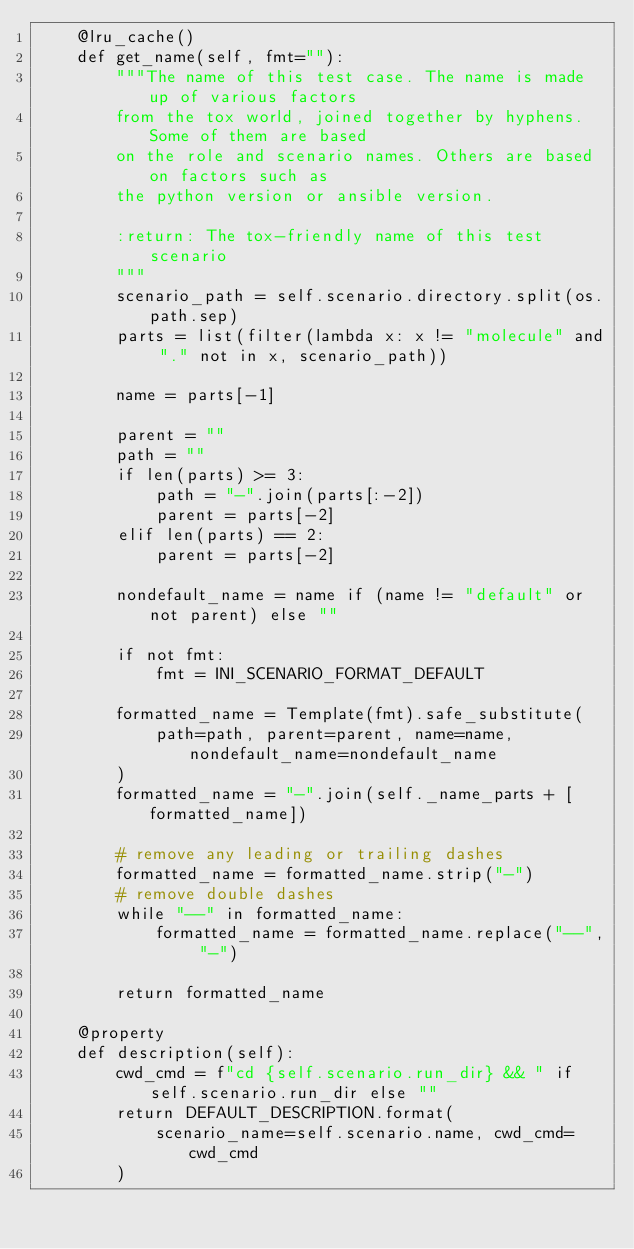<code> <loc_0><loc_0><loc_500><loc_500><_Python_>    @lru_cache()
    def get_name(self, fmt=""):
        """The name of this test case. The name is made up of various factors
        from the tox world, joined together by hyphens. Some of them are based
        on the role and scenario names. Others are based on factors such as
        the python version or ansible version.

        :return: The tox-friendly name of this test scenario
        """
        scenario_path = self.scenario.directory.split(os.path.sep)
        parts = list(filter(lambda x: x != "molecule" and "." not in x, scenario_path))

        name = parts[-1]

        parent = ""
        path = ""
        if len(parts) >= 3:
            path = "-".join(parts[:-2])
            parent = parts[-2]
        elif len(parts) == 2:
            parent = parts[-2]

        nondefault_name = name if (name != "default" or not parent) else ""

        if not fmt:
            fmt = INI_SCENARIO_FORMAT_DEFAULT

        formatted_name = Template(fmt).safe_substitute(
            path=path, parent=parent, name=name, nondefault_name=nondefault_name
        )
        formatted_name = "-".join(self._name_parts + [formatted_name])

        # remove any leading or trailing dashes
        formatted_name = formatted_name.strip("-")
        # remove double dashes
        while "--" in formatted_name:
            formatted_name = formatted_name.replace("--", "-")

        return formatted_name

    @property
    def description(self):
        cwd_cmd = f"cd {self.scenario.run_dir} && " if self.scenario.run_dir else ""
        return DEFAULT_DESCRIPTION.format(
            scenario_name=self.scenario.name, cwd_cmd=cwd_cmd
        )
</code> 